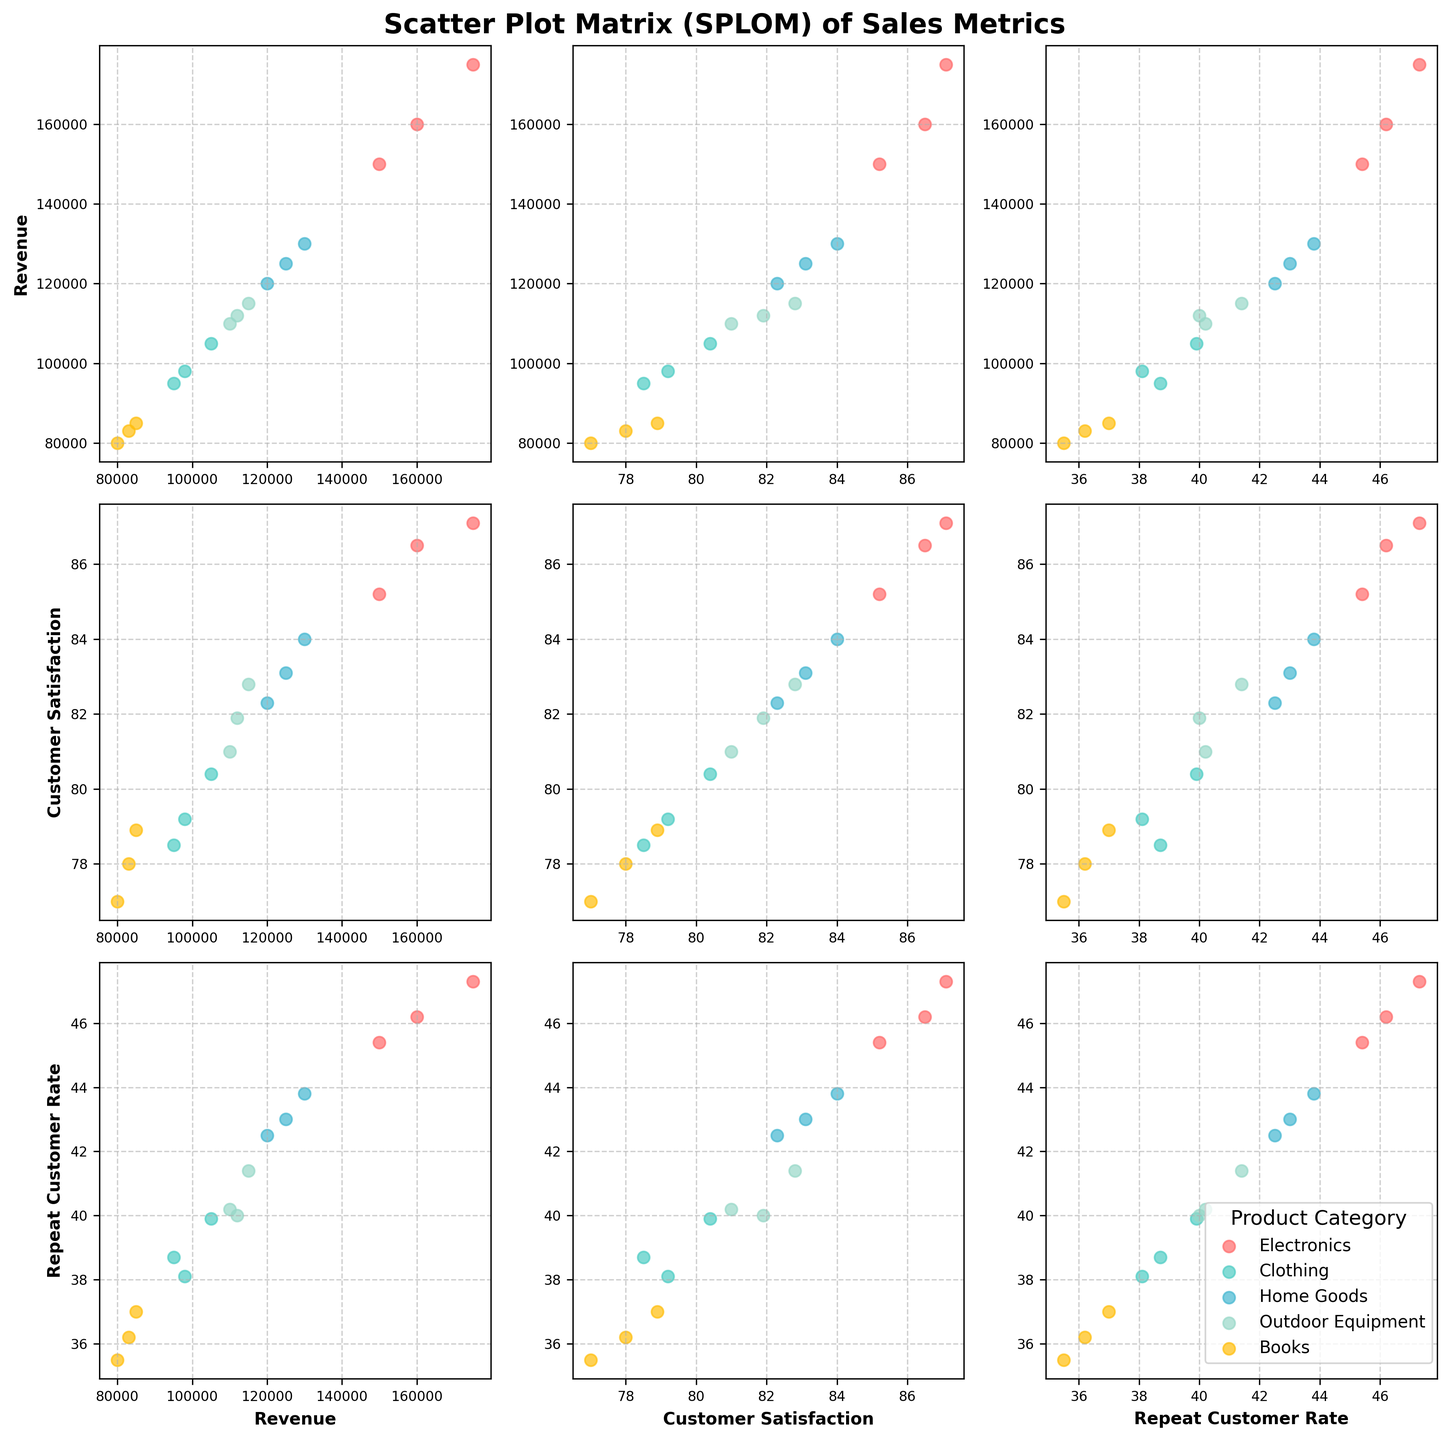What is the title of the figure? The figure title is usually found at the top of the graphical representation, indicating the subject or focus of the figure.
Answer: Scatter Plot Matrix (SPLOM) of Sales Metrics How many data points are there in the 'Electronics' category? By locating the scatter points labeled 'Electronics' in any subplot, we can count the occurrences. This will be the same in every plot since the data is consistent across the figure. There are 3 scatter points for 'Electronics'.
Answer: 3 Which product category shows the highest customer satisfaction? To determine this, we compare the average customer satisfaction values for each product category by visually inspecting the corresponding axis in the scatter plots. The 'Electronics' category has the highest average customer satisfaction.
Answer: Electronics What color is associated with 'Home Goods'? Colors associated with product categories are indicated in the legend box. By referring to the legend, one can identify that 'Home Goods' is represented by a particular color.
Answer: #45B7D1 Between 'Revenue' and 'Repeat Customer Rate', which plot exhibits the widest spread for the 'Clothing' category? By looking at the scatter plots in the row for 'Revenue' and column for 'Repeat Customer Rate', we compare the spread of 'Clothing' data points in terms of their dispersion. 'Revenue' demonstrates a wider spread for 'Clothing'.
Answer: Revenue How do 'Books' compare to 'Outdoor Equipment' in terms of average revenue? To compare, we visually assess the central tendency (middle point) of 'Books' and 'Outdoor Equipment' on the 'Revenue' axes in their respective plots. 'Books' has a lower average revenue compared to 'Outdoor Equipment'.
Answer: Outdoor Equipment has higher average revenue For 'Electronics', what is the relationship between higher revenue and customer satisfaction? By examining the scatter plot between 'Revenue' and 'Customer Satisfaction' for 'Electronics', we look for the trend in how the points are arranged. Higher revenue tends to correlate with higher customer satisfaction for 'Electronics'.
Answer: Positive correlation What does the scatter plot between 'Customer Satisfaction' and 'Repeat Customer Rate' generally suggest about their relationship across all product categories? Reviewing the array of scatter points for this specific plot, we can determine a trend or lack thereof. There appears to be a positive correlation between customer satisfaction and repeat customer rate.
Answer: Positive correlation Which product category has the lowest repeat customer rate and what is the rate? By glancing at the lowest positions of the data points on the 'Repeat Customer Rate' axis, we identify and note the category and specific rate. 'Books' has the lowest repeat customer rate. The rate for 'Books' is around 35.5.
Answer: Books, 35.5 What is the general trend between 'Revenue' and 'Repeat Customer Rate' for 'Home Goods'? By observing the scatter plot involving 'Revenue' and 'Repeat Customer Rate,' specific to 'Home Goods', we see if higher revenues lead to higher repeat customer rates. There seems to be a positive trend for 'Home Goods'.
Answer: Positive trend 